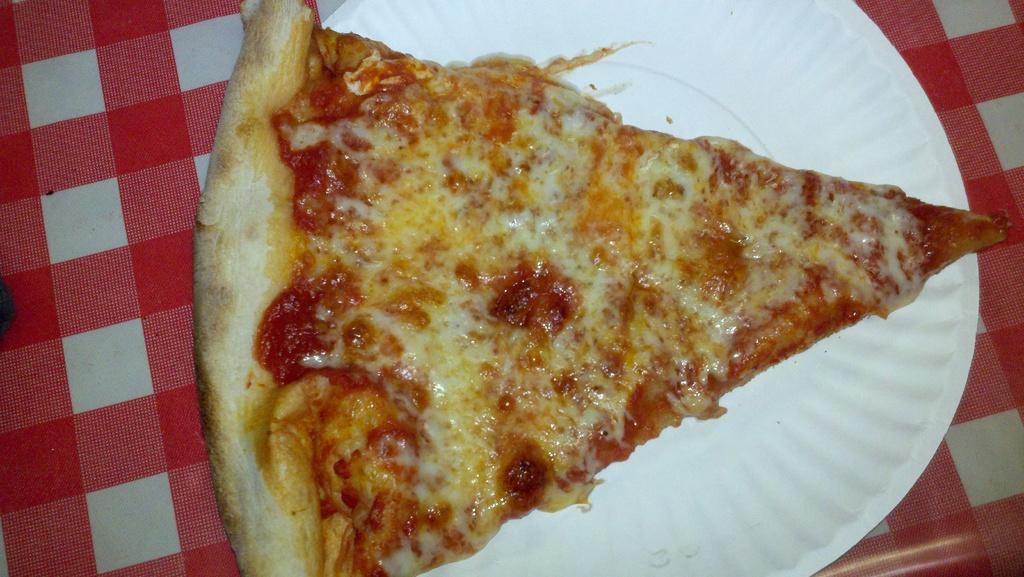What type of food is shown in the image? There is a slice of pizza in the image. What is the pizza placed on? The pizza is placed on a plate in the image. Where are the pizza and plate located? The pizza and plate are placed on a table in the image. How many pizzas are being played with at the playground in the image? There is no playground or additional pizzas present in the image; it only shows a slice of pizza on a plate. 